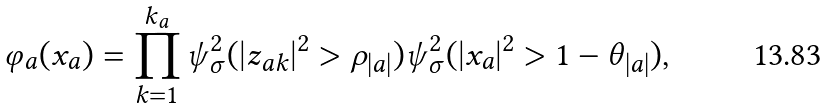<formula> <loc_0><loc_0><loc_500><loc_500>\varphi _ { a } ( x _ { a } ) = \prod _ { k = 1 } ^ { k _ { a } } \psi ^ { 2 } _ { \sigma } ( | z _ { a k } | ^ { 2 } > \rho _ { | a | } ) \psi ^ { 2 } _ { \sigma } ( | x _ { a } | ^ { 2 } > 1 - \theta _ { | a | } ) ,</formula> 